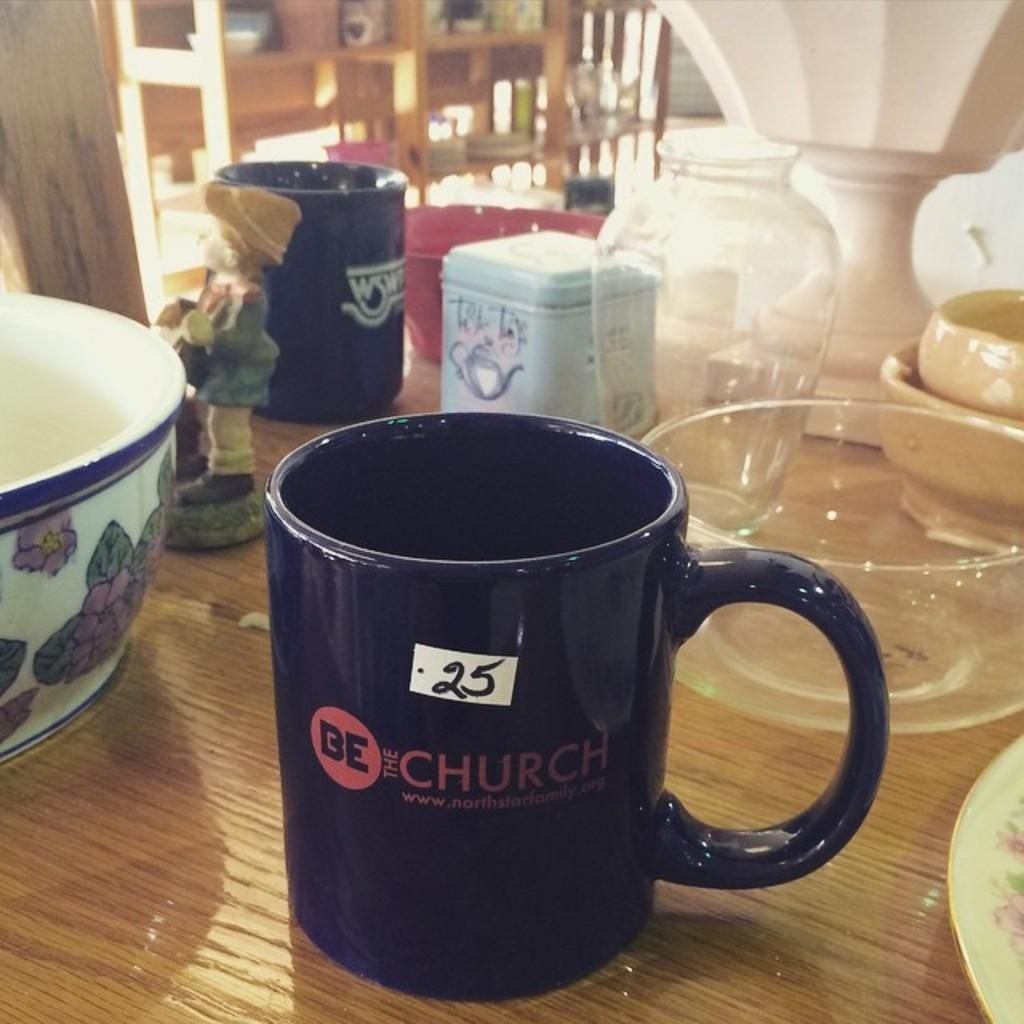<image>
Describe the image concisely. A tag sale which a variety of cups and bowls, one cup with the writing Be the Church on it 